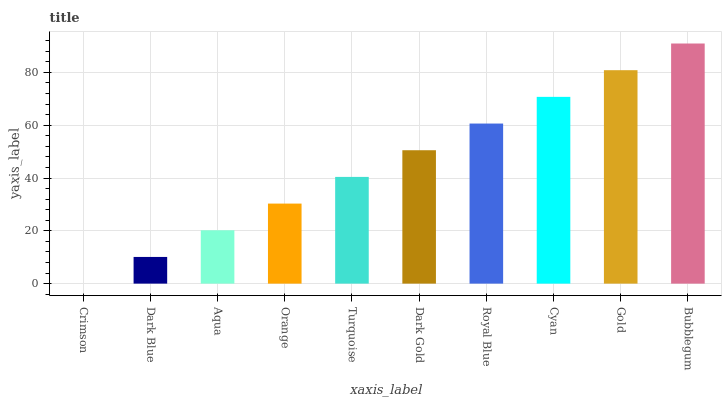Is Crimson the minimum?
Answer yes or no. Yes. Is Bubblegum the maximum?
Answer yes or no. Yes. Is Dark Blue the minimum?
Answer yes or no. No. Is Dark Blue the maximum?
Answer yes or no. No. Is Dark Blue greater than Crimson?
Answer yes or no. Yes. Is Crimson less than Dark Blue?
Answer yes or no. Yes. Is Crimson greater than Dark Blue?
Answer yes or no. No. Is Dark Blue less than Crimson?
Answer yes or no. No. Is Dark Gold the high median?
Answer yes or no. Yes. Is Turquoise the low median?
Answer yes or no. Yes. Is Royal Blue the high median?
Answer yes or no. No. Is Cyan the low median?
Answer yes or no. No. 